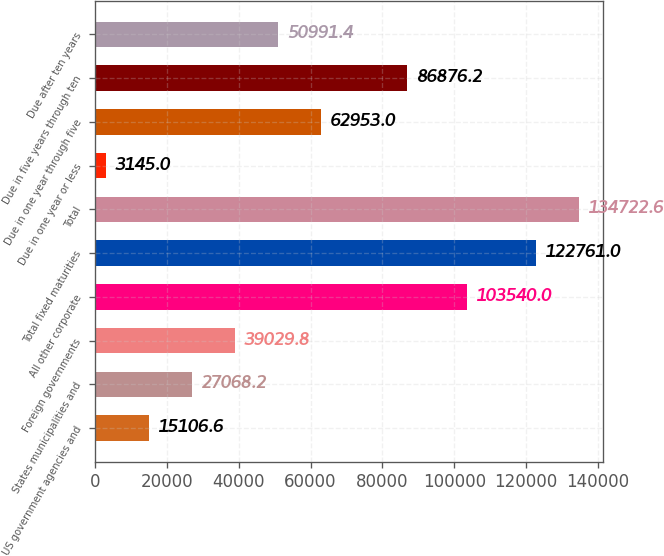<chart> <loc_0><loc_0><loc_500><loc_500><bar_chart><fcel>US government agencies and<fcel>States municipalities and<fcel>Foreign governments<fcel>All other corporate<fcel>Total fixed maturities<fcel>Total<fcel>Due in one year or less<fcel>Due in one year through five<fcel>Due in five years through ten<fcel>Due after ten years<nl><fcel>15106.6<fcel>27068.2<fcel>39029.8<fcel>103540<fcel>122761<fcel>134723<fcel>3145<fcel>62953<fcel>86876.2<fcel>50991.4<nl></chart> 